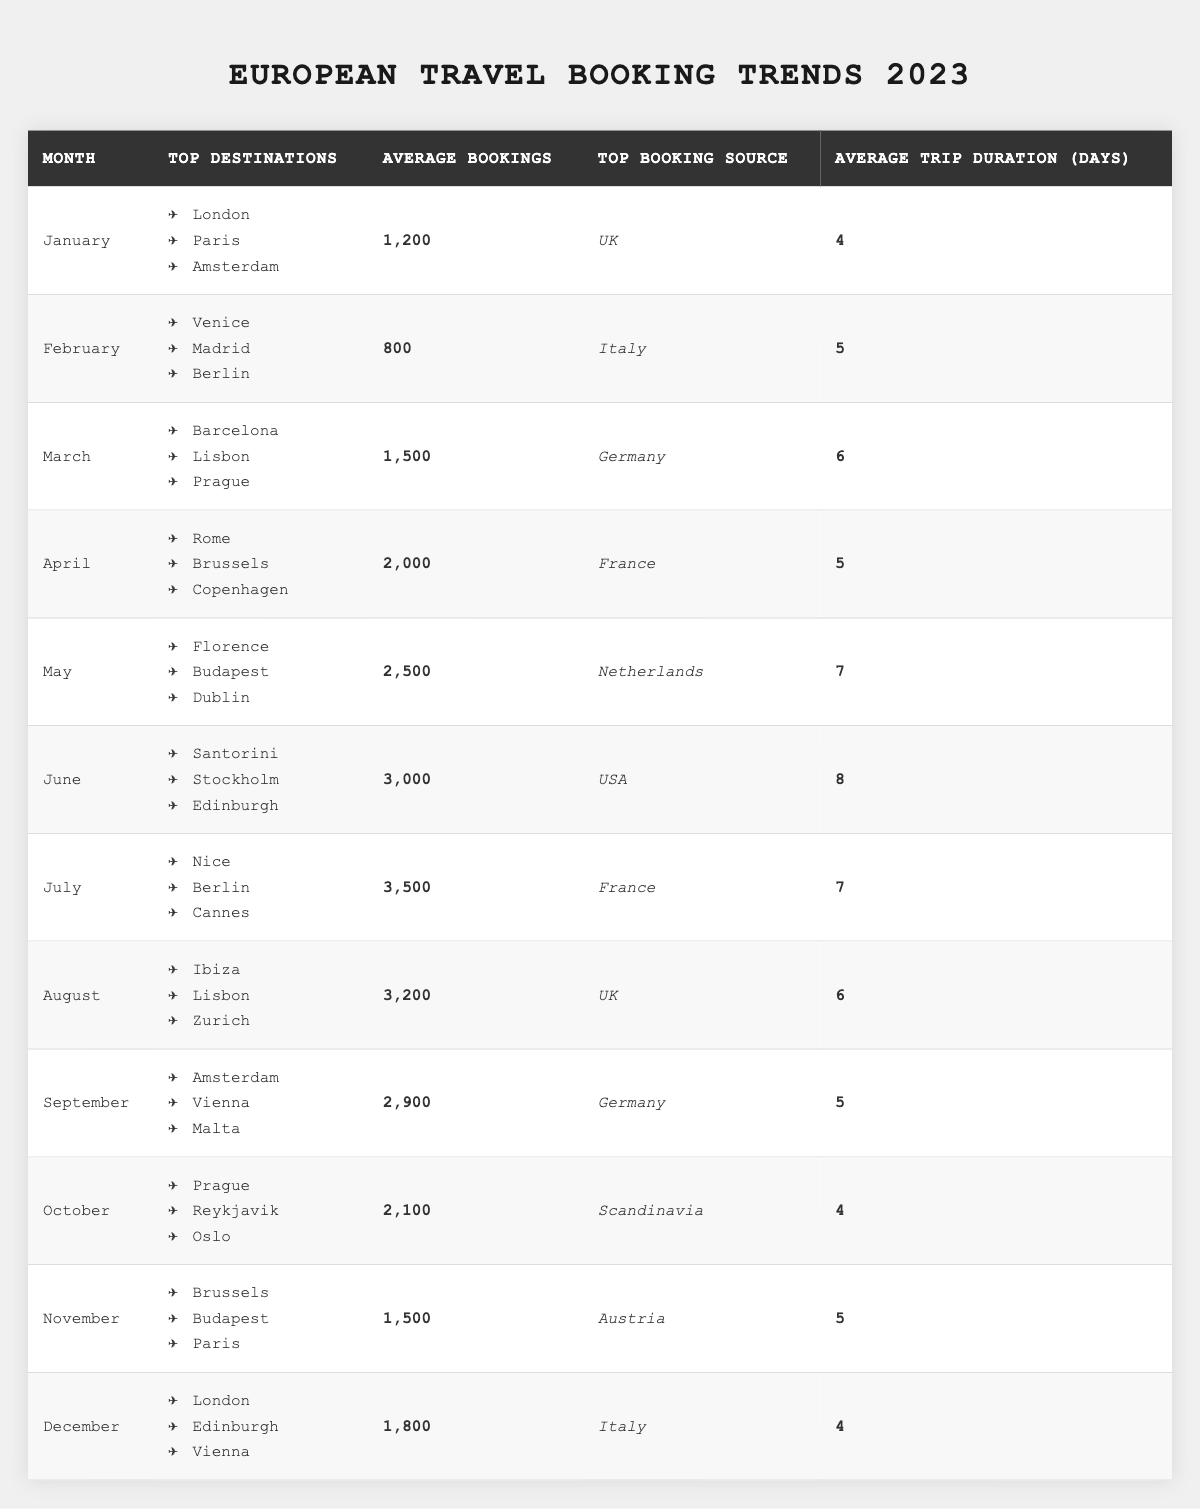What were the top three destinations in May? According to the table, the top three destinations in May are Florence, Budapest, and Dublin.
Answer: Florence, Budapest, Dublin What was the average number of bookings in June? The average bookings for June is provided directly in the table as 3000.
Answer: 3000 Is the top booking source for July France? The table clearly states that the top booking source for July is France.
Answer: Yes Which month had the highest average bookings? By examining the average bookings for each month, July shows the highest average at 3500.
Answer: July What is the difference in average bookings between April and February? The average bookings in April is 2000, and in February, it is 800. The difference is calculated as 2000 - 800 = 1200.
Answer: 1200 In which month do travelers stay the longest on average? From the data, June has the longest average trip duration at 8 days.
Answer: June Which two months had the same average trip duration? By reviewing the table, both November and February had an average trip duration of 5 days.
Answer: November, February What is the average number of bookings for the first half of the year (January to June)? The average bookings for the months January to June are 1200, 800, 1500, 2000, 2500, and 3000. Summing these gives 1200 + 800 + 1500 + 2000 + 2500 + 3000 = 12000, and dividing by 6 gives an average of 12000 / 6 = 2000.
Answer: 2000 Which country produced the largest booking source by percentage in August? In August, the top booking source is the UK, with 3200 bookings. Without further data, it’s assumed that this is the largest source as it is listed first.
Answer: UK What was the average trip duration for the months with more than 2000 bookings? The months with more than 2000 bookings are May (7 days), June (8 days), and July (7 days). The average trip duration is calculated as (7 + 8 + 7) / 3 = 22 / 3 = approximately 7.33 days.
Answer: 7.33 days 